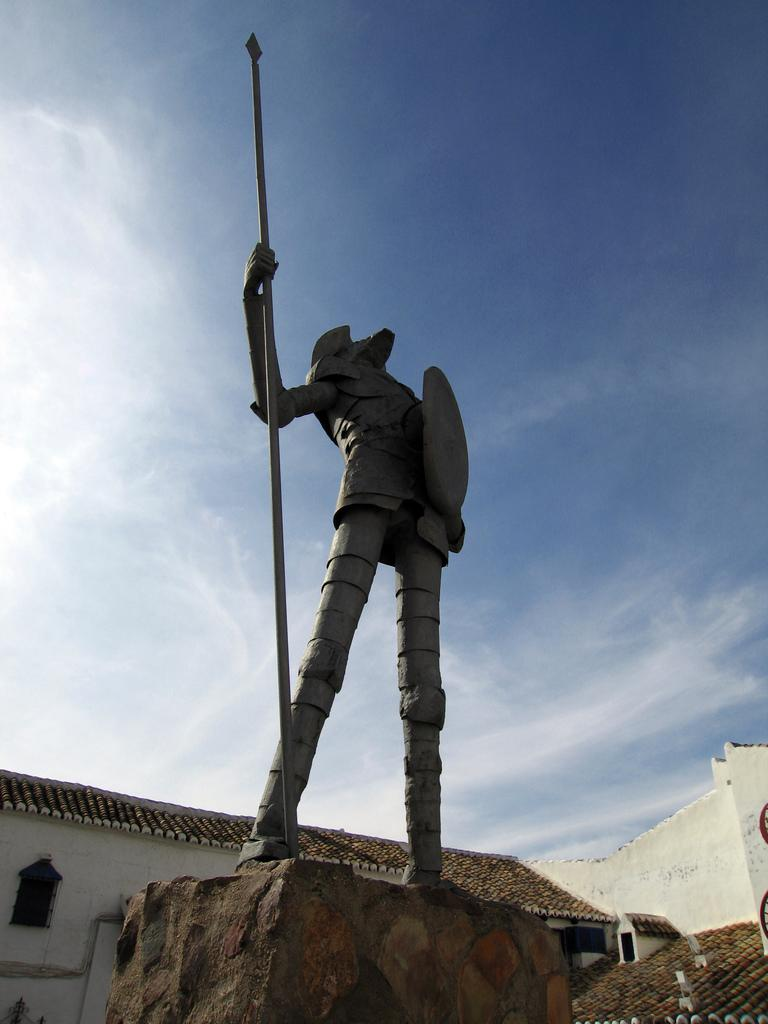What is the main subject in the image? There is a statue in the image. What is the statue resting on? The statue is on an object. What type of structures can be seen in the image? There are houses visible in the image. What is visible in the background of the image? The sky is visible in the image, and clouds are present in the sky. How many frogs are sitting on the statue in the image? There are no frogs present in the image, so it is not possible to determine how many might be sitting on the statue. 